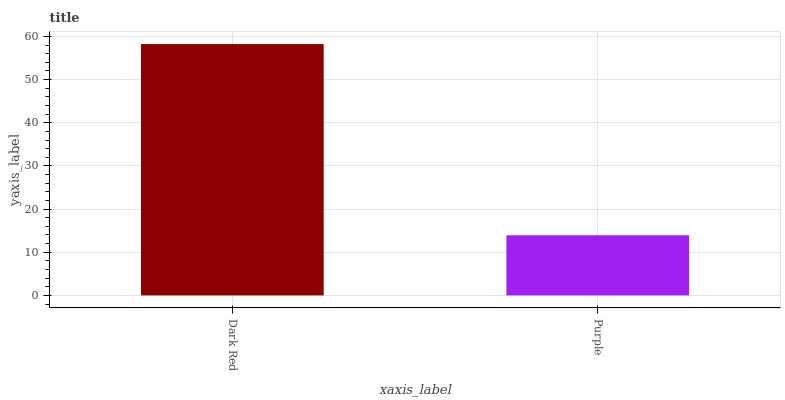Is Purple the minimum?
Answer yes or no. Yes. Is Dark Red the maximum?
Answer yes or no. Yes. Is Purple the maximum?
Answer yes or no. No. Is Dark Red greater than Purple?
Answer yes or no. Yes. Is Purple less than Dark Red?
Answer yes or no. Yes. Is Purple greater than Dark Red?
Answer yes or no. No. Is Dark Red less than Purple?
Answer yes or no. No. Is Dark Red the high median?
Answer yes or no. Yes. Is Purple the low median?
Answer yes or no. Yes. Is Purple the high median?
Answer yes or no. No. Is Dark Red the low median?
Answer yes or no. No. 